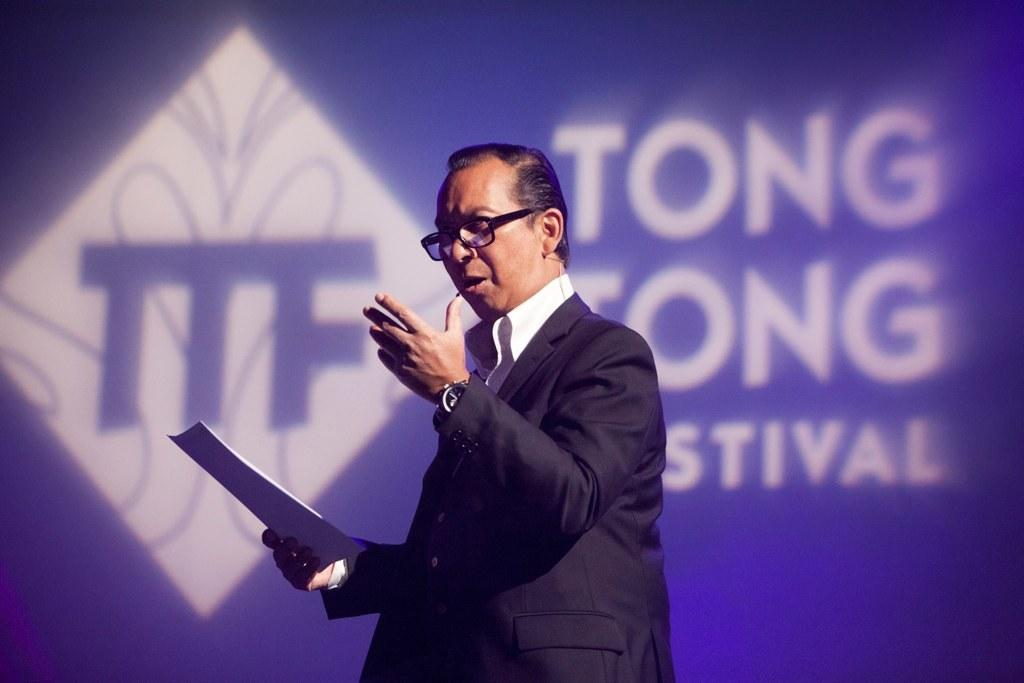What is the main subject of the image? The main subject of the image is a man. What is the man doing in the image? The man is standing in the image. What is the man holding in the image? The man is holding an object in the image. What type of eyewear is the man wearing? The man is wearing shades in the image. What can be seen in the background of the image? There is text or writing visible in the background of the image. What time is displayed on the clock in the image? There is no clock present in the image. What type of ring is the man wearing on his finger in the image? There is no ring visible on the man's finger in the image. 